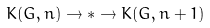<formula> <loc_0><loc_0><loc_500><loc_500>K ( G , n ) \to * \to K ( G , n + 1 )</formula> 